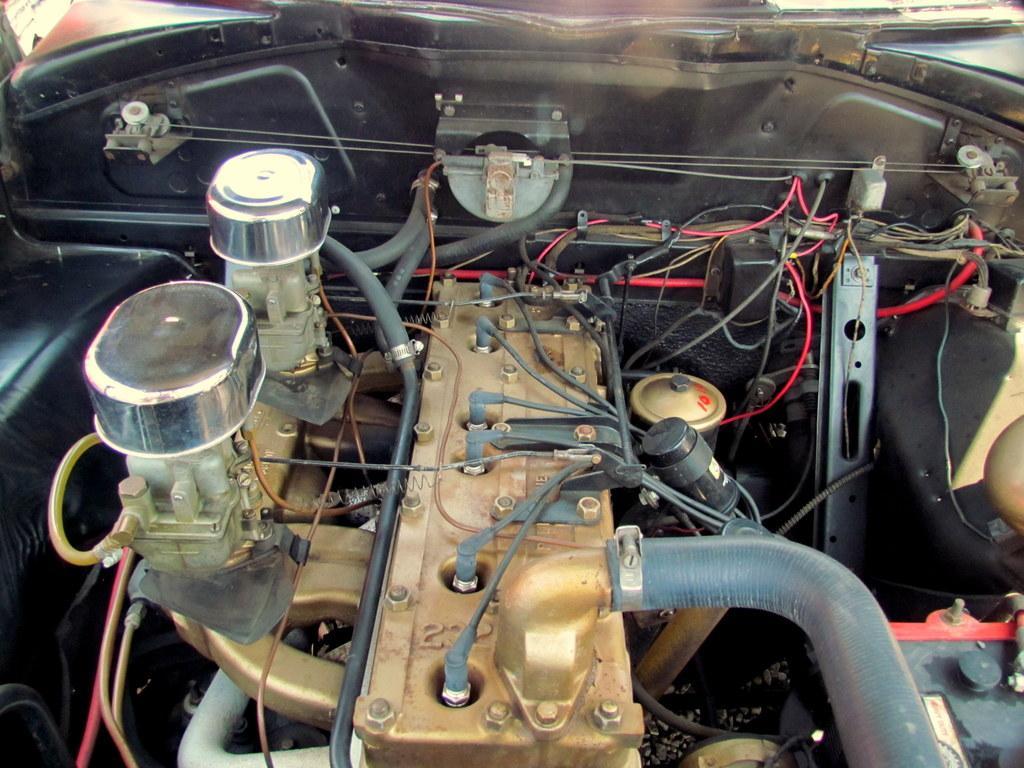Please provide a concise description of this image. This image consists of a car. In the front, we can see an engine of a car. And there are many wires in this image. 